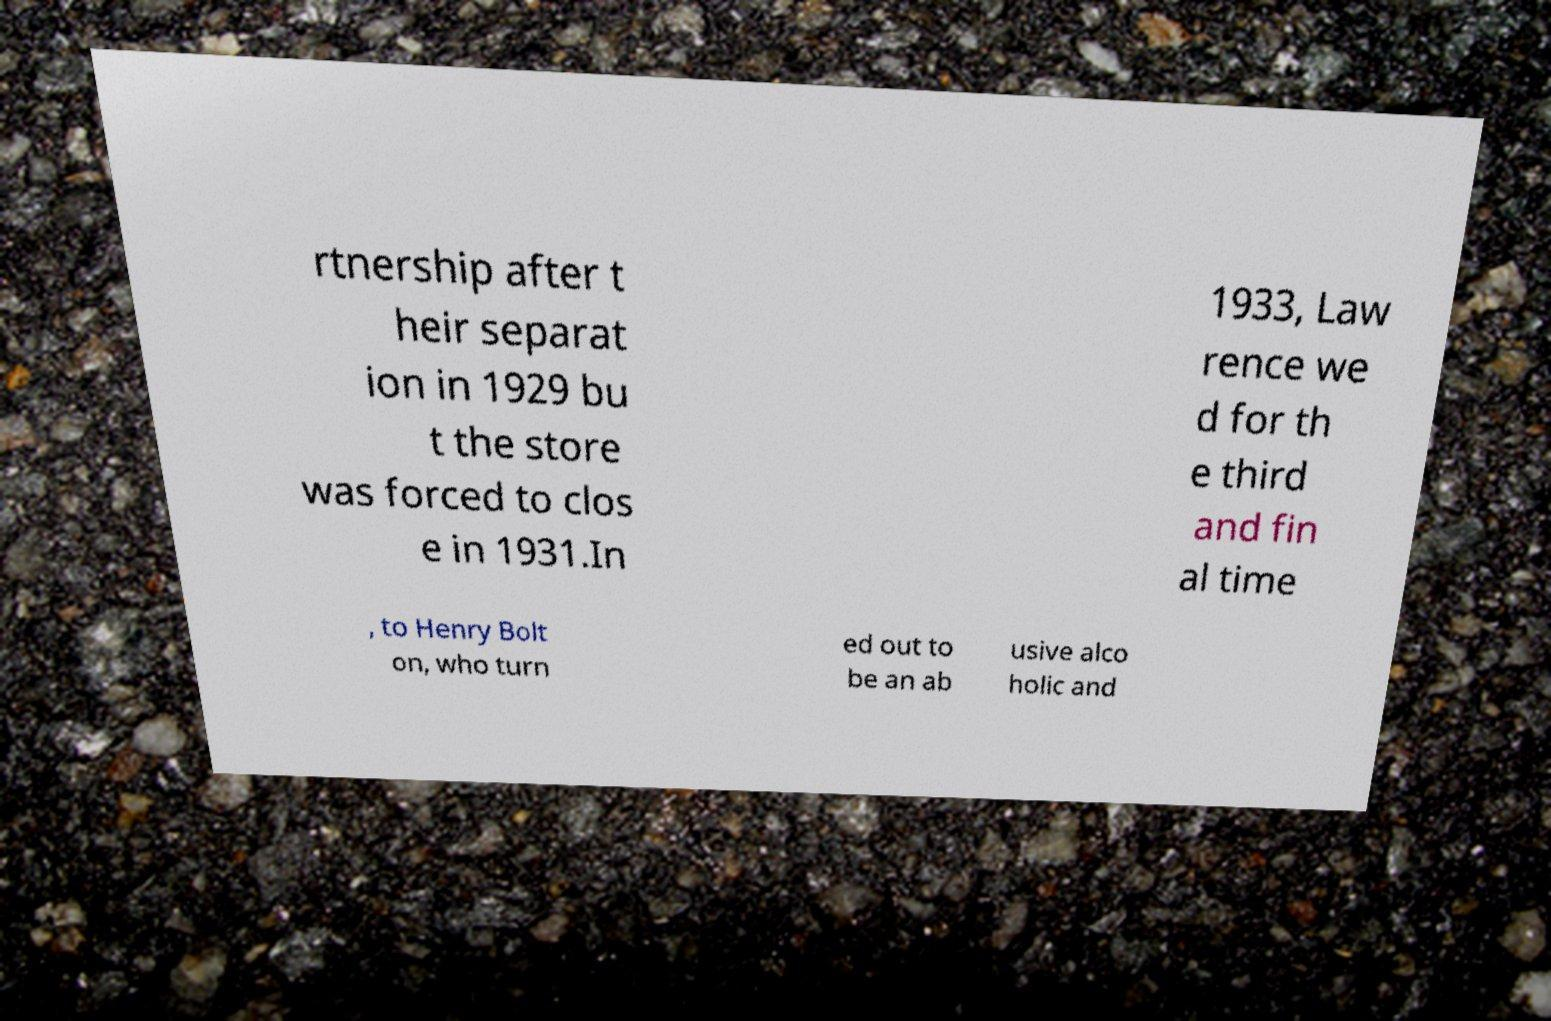For documentation purposes, I need the text within this image transcribed. Could you provide that? rtnership after t heir separat ion in 1929 bu t the store was forced to clos e in 1931.In 1933, Law rence we d for th e third and fin al time , to Henry Bolt on, who turn ed out to be an ab usive alco holic and 